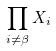Convert formula to latex. <formula><loc_0><loc_0><loc_500><loc_500>\prod _ { i \ne \beta } X _ { i }</formula> 